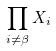Convert formula to latex. <formula><loc_0><loc_0><loc_500><loc_500>\prod _ { i \ne \beta } X _ { i }</formula> 